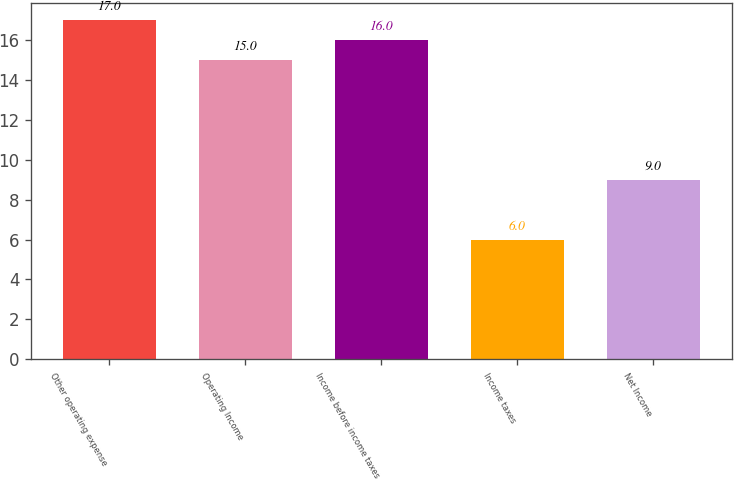Convert chart. <chart><loc_0><loc_0><loc_500><loc_500><bar_chart><fcel>Other operating expense<fcel>Operating Income<fcel>Income before income taxes<fcel>Income taxes<fcel>Net Income<nl><fcel>17<fcel>15<fcel>16<fcel>6<fcel>9<nl></chart> 